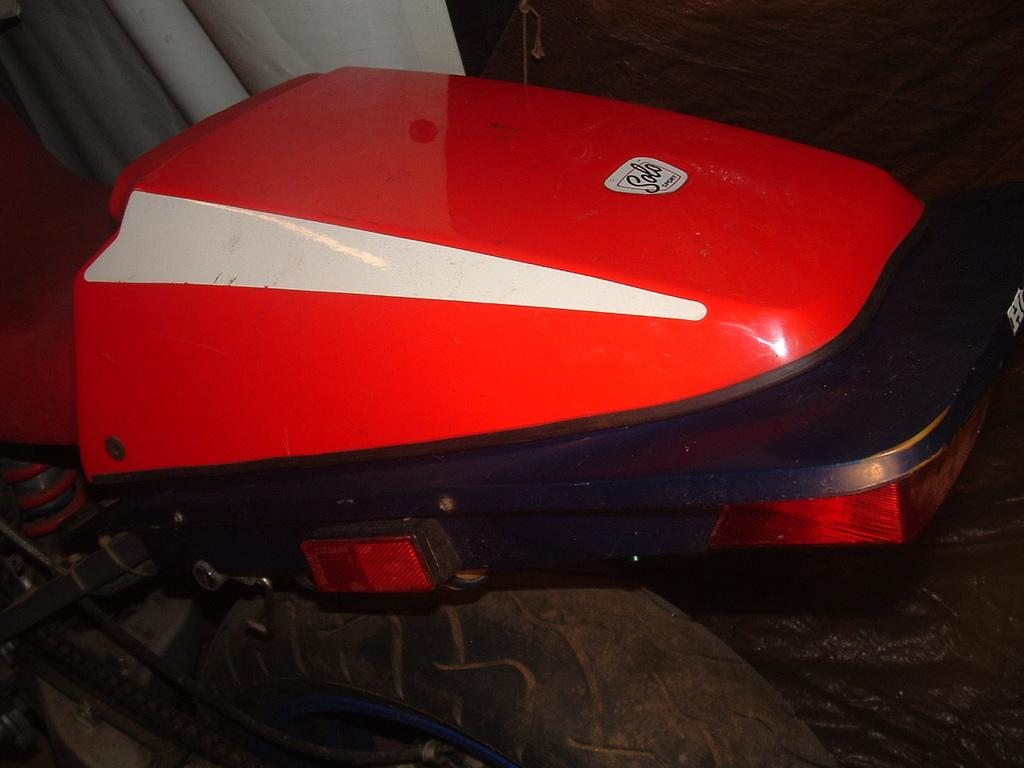What is the main subject of the picture? The main subject of the picture is a vehicle. What color is the vehicle? The vehicle is red in color. Are there any distinguishing features on the vehicle? Yes, there is a logo on the vehicle. In which direction is the ornament on the vehicle facing? There is no ornament mentioned in the facts provided, so we cannot determine its direction. 